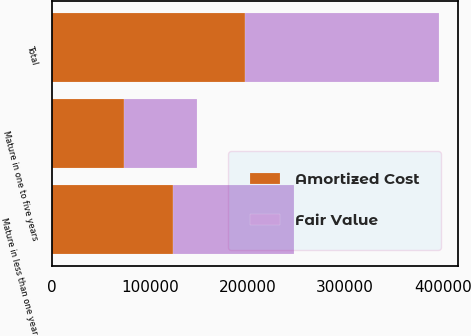<chart> <loc_0><loc_0><loc_500><loc_500><stacked_bar_chart><ecel><fcel>Mature in less than one year<fcel>Mature in one to five years<fcel>Total<nl><fcel>Fair Value<fcel>124286<fcel>74506<fcel>198792<nl><fcel>Amortized Cost<fcel>123679<fcel>73552<fcel>197231<nl></chart> 